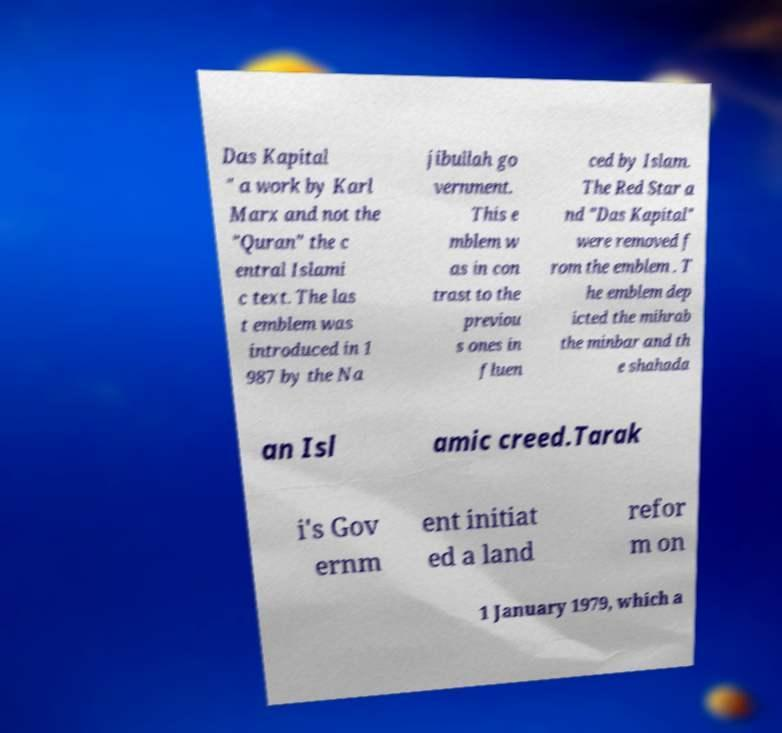Could you assist in decoding the text presented in this image and type it out clearly? Das Kapital " a work by Karl Marx and not the "Quran" the c entral Islami c text. The las t emblem was introduced in 1 987 by the Na jibullah go vernment. This e mblem w as in con trast to the previou s ones in fluen ced by Islam. The Red Star a nd "Das Kapital" were removed f rom the emblem . T he emblem dep icted the mihrab the minbar and th e shahada an Isl amic creed.Tarak i's Gov ernm ent initiat ed a land refor m on 1 January 1979, which a 